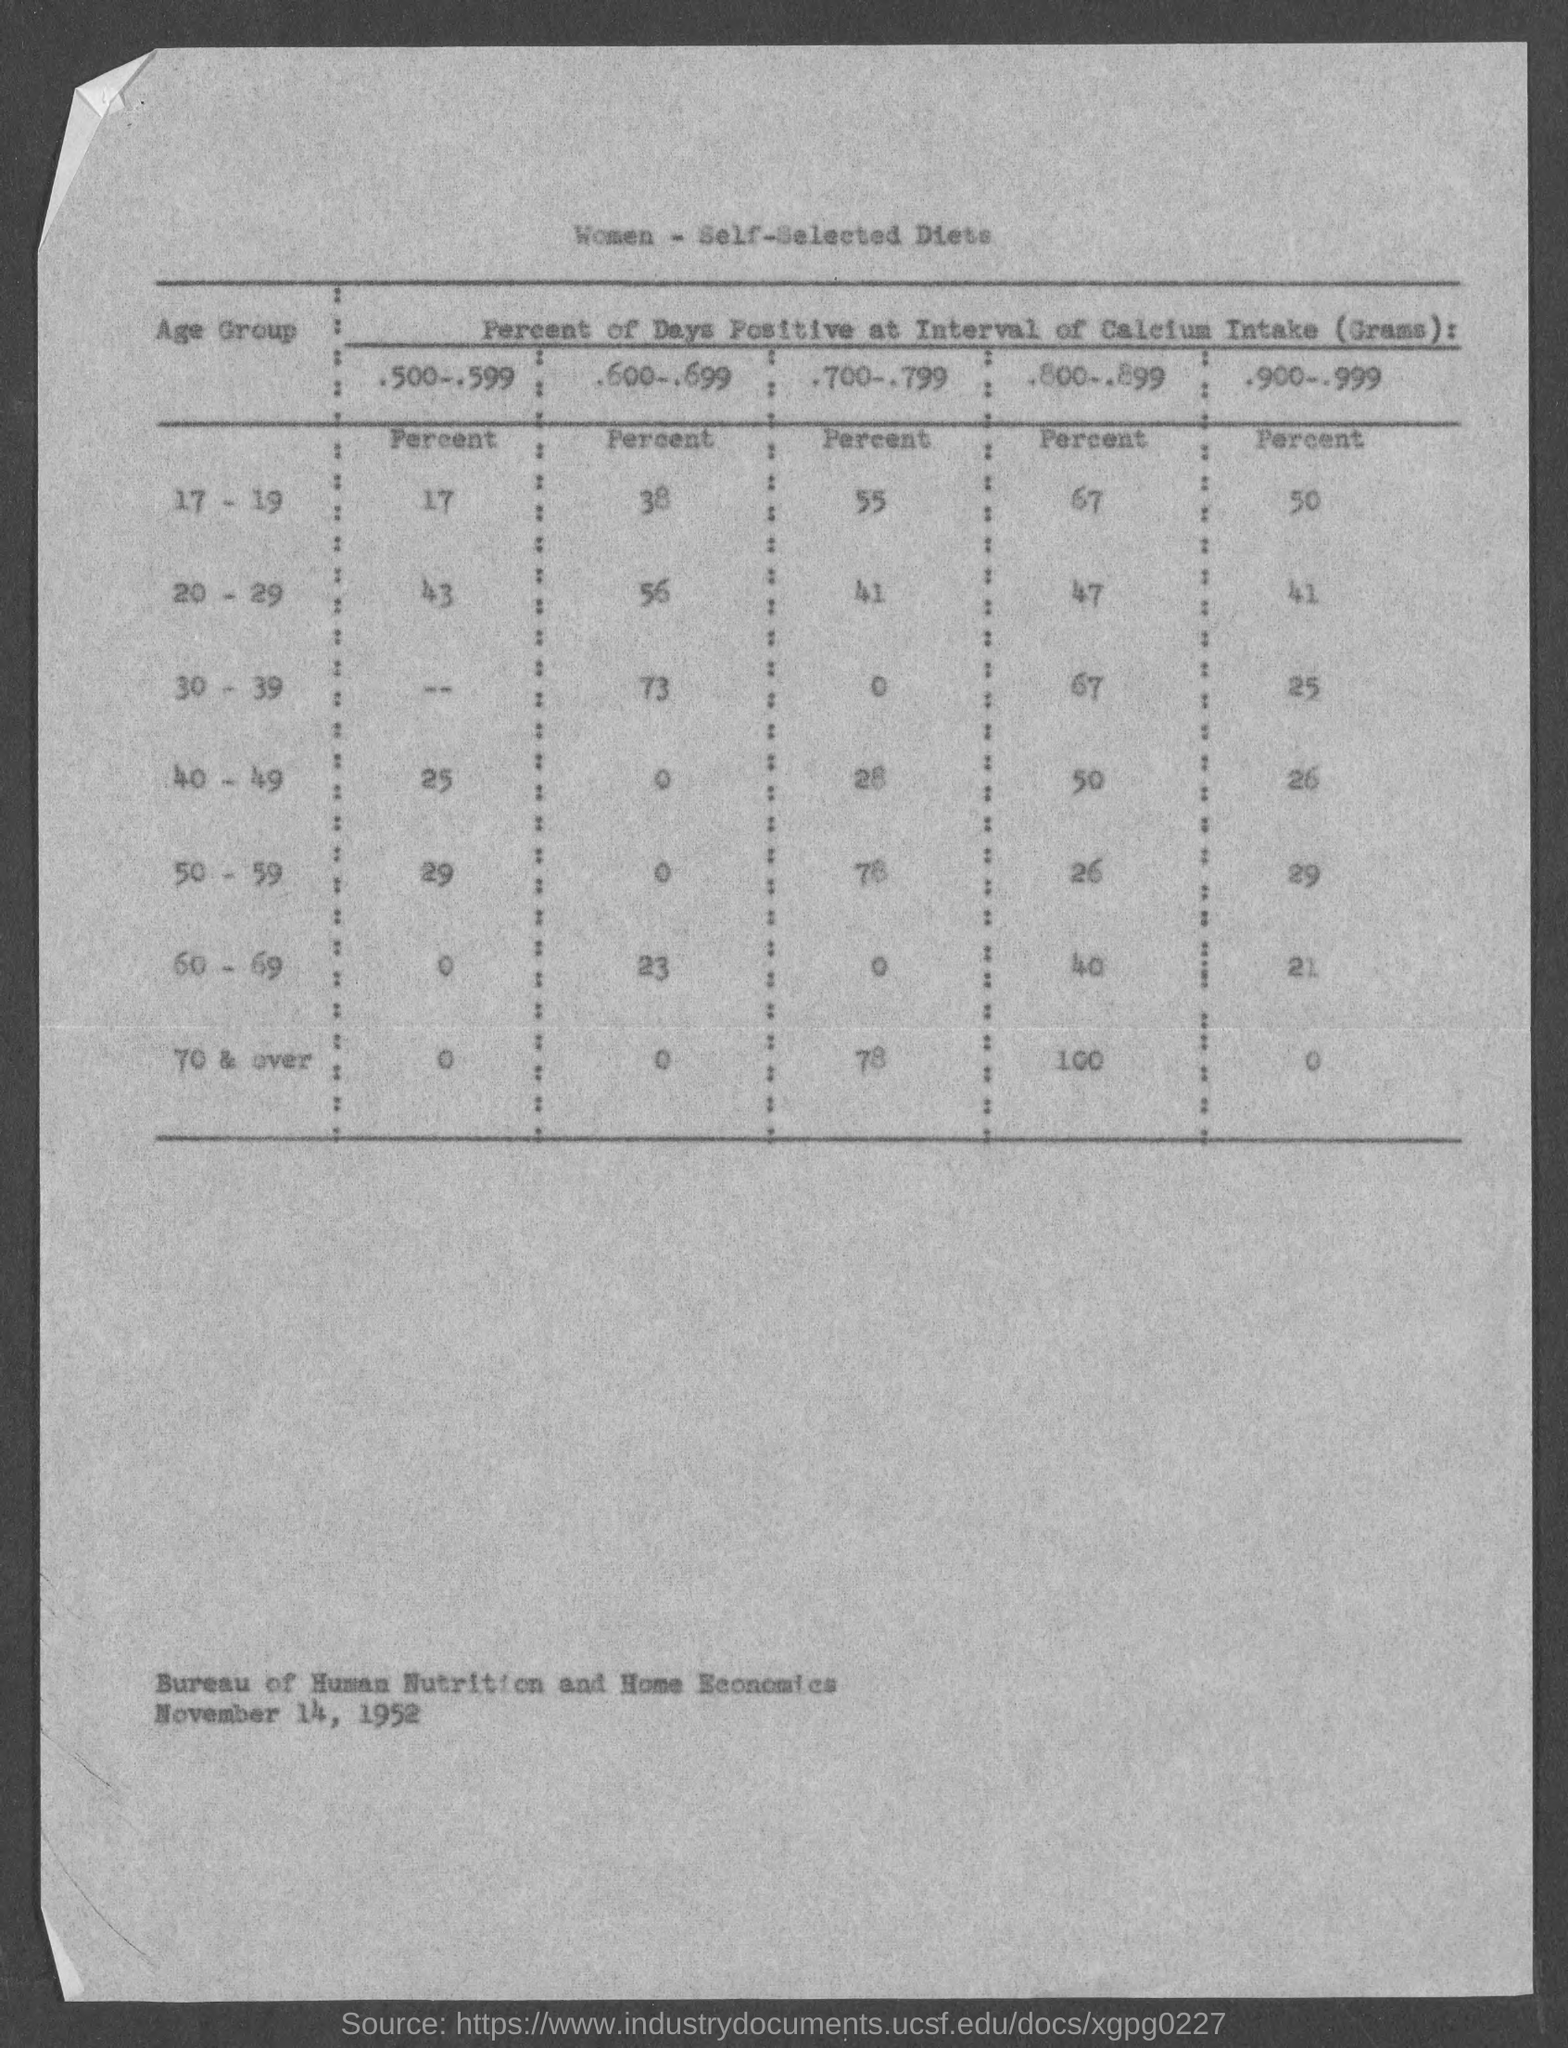Indicate a few pertinent items in this graphic. The table title is "What is the table title? women - self-selected diets.. Approximately 25% of the days for individuals in the age group of 17-19 fall under the category of having a win percentage of .500 to .599. 